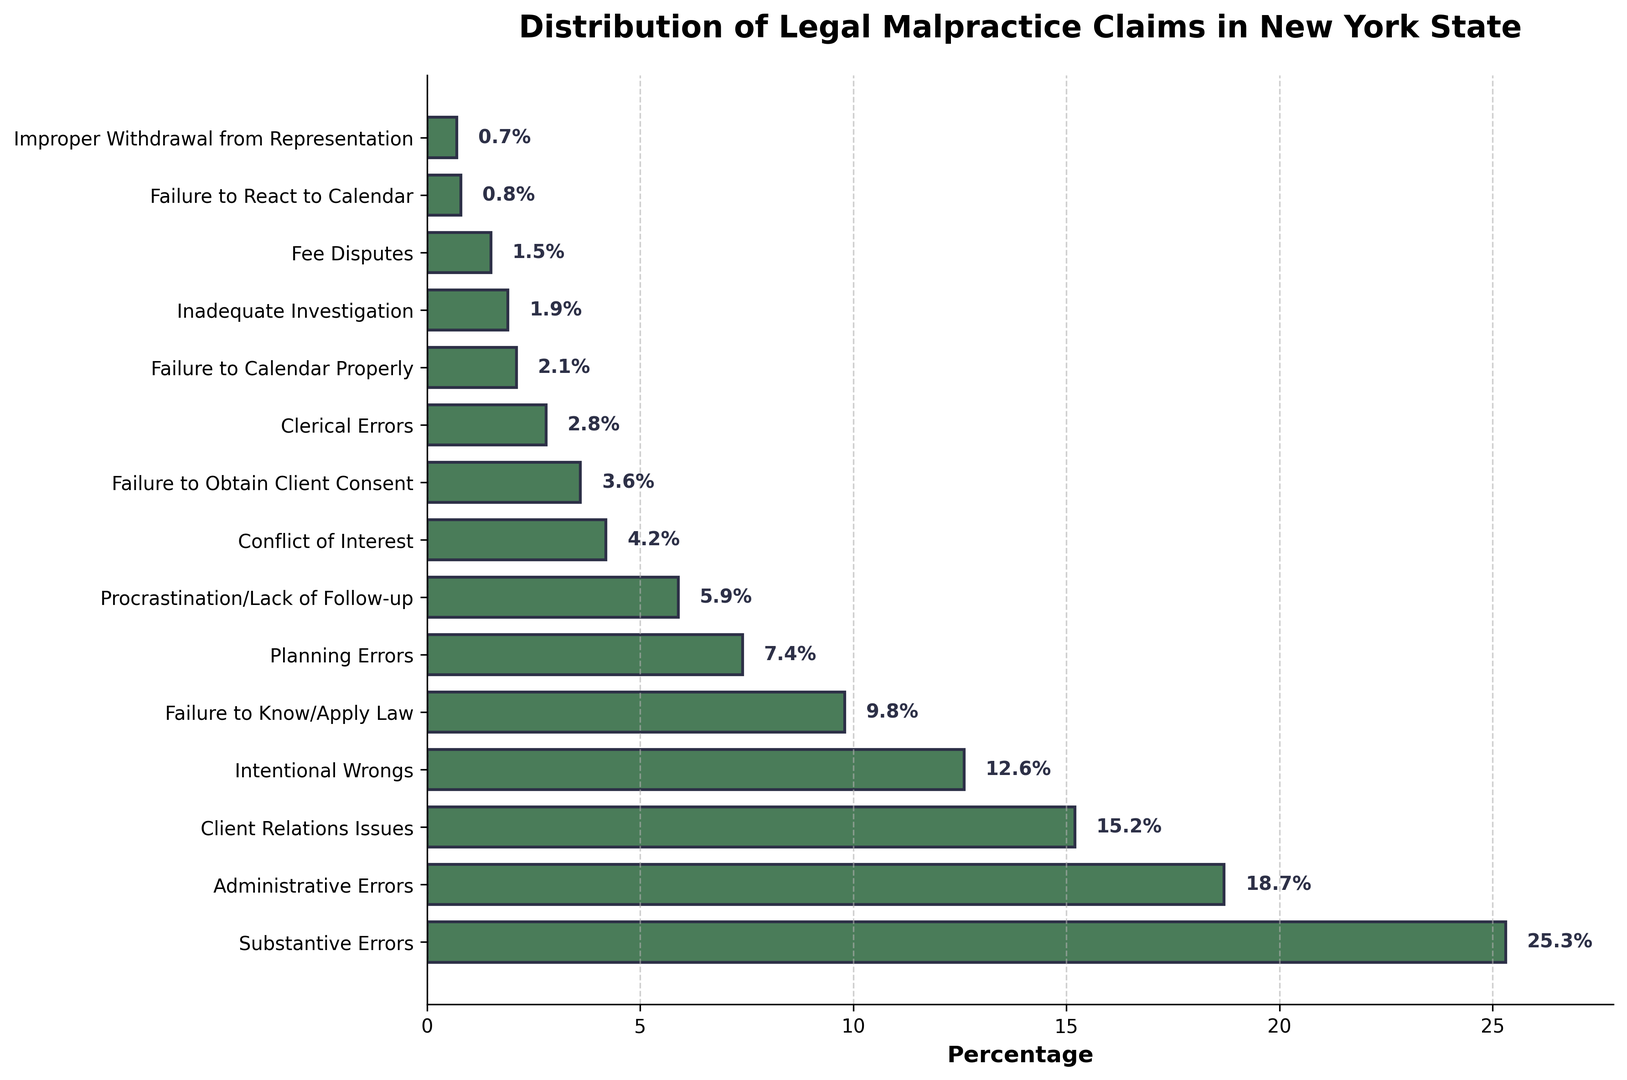What type of alleged error contributes the most to legal malpractice claims? Observe the lengths of the bars; the longest bar represents "Substantive Errors".
Answer: Substantive Errors Which type of alleged error is more common, Planning Errors or Administrative Errors? Compare the lengths of the bars for "Planning Errors" and "Administrative Errors". "Administrative Errors" has a longer bar.
Answer: Administrative Errors What is the combined percentage of claims attributed to "Substantive Errors" and "Administrative Errors"? Look at the percentages for "Substantive Errors" (25.3%) and "Administrative Errors" (18.7%) and add them together: 25.3 + 18.7 = 44.0.
Answer: 44.0% How much higher is the percentage of "Substantive Errors" compared to "Failure to Know/Apply Law"? Subtract the percentage of "Failure to Know/Apply Law" (9.8%) from "Substantive Errors" (25.3%): 25.3 - 9.8 = 15.5.
Answer: 15.5% Are Client Relations Issues or Conflict of Interest more significant in terms of the percentage of claims? Compare the percentages for "Client Relations Issues" (15.2%) and "Conflict of Interest" (4.2%). "Client Relations Issues" has a higher percentage.
Answer: Client Relations Issues What percentage of claims are attributed to "Failure to Calendar Properly" and "Improper Withdrawal from Representation" combined? Add the percentages for "Failure to Calendar Properly" (2.1%) and "Improper Withdrawal from Representation" (0.7%): 2.1 + 0.7 = 2.8.
Answer: 2.8% Which type of alleged error has the smallest percentage of claims, and what is that percentage? Identify the shortest bar, which corresponds to "Improper Withdrawal from Representation" with a percentage of 0.7%.
Answer: Improper Withdrawal from Representation, 0.7% What is the percentage difference between "Intentional Wrongs" and "Failure to Obtain Client Consent"? Subtract the percentage for "Failure to Obtain Client Consent" (3.6%) from "Intentional Wrongs" (12.6%): 12.6 - 3.6 = 9.0.
Answer: 9.0 List the types of alleged errors with percentages greater than 10%. Identify the bars with values over 10%: "Substantive Errors" (25.3%), "Administrative Errors" (18.7%), "Client Relations Issues" (15.2%), and "Intentional Wrongs" (12.6%).
Answer: Substantive Errors, Administrative Errors, Client Relations Issues, Intentional Wrongs What is the median value of the percentages of all types of alleged errors? List the percentages in ascending order: 0.7, 0.8, 1.5, 1.9, 2.1, 2.8, 3.6, 4.2, 5.9, 7.4, 9.8, 12.6, 15.2, 18.7, 25.3. The median is the middle value, which is 5.9%.
Answer: 5.9% 